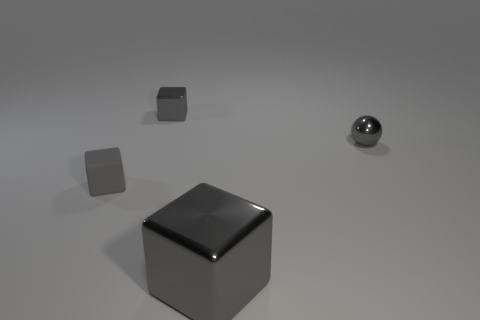Subtract all small gray blocks. How many blocks are left? 1 Add 3 tiny metallic blocks. How many objects exist? 7 Subtract all blocks. How many objects are left? 1 Subtract 1 spheres. How many spheres are left? 0 Add 4 gray metallic spheres. How many gray metallic spheres exist? 5 Subtract 0 green cylinders. How many objects are left? 4 Subtract all brown spheres. Subtract all gray cylinders. How many spheres are left? 1 Subtract all red balls. Subtract all tiny objects. How many objects are left? 1 Add 4 tiny shiny things. How many tiny shiny things are left? 6 